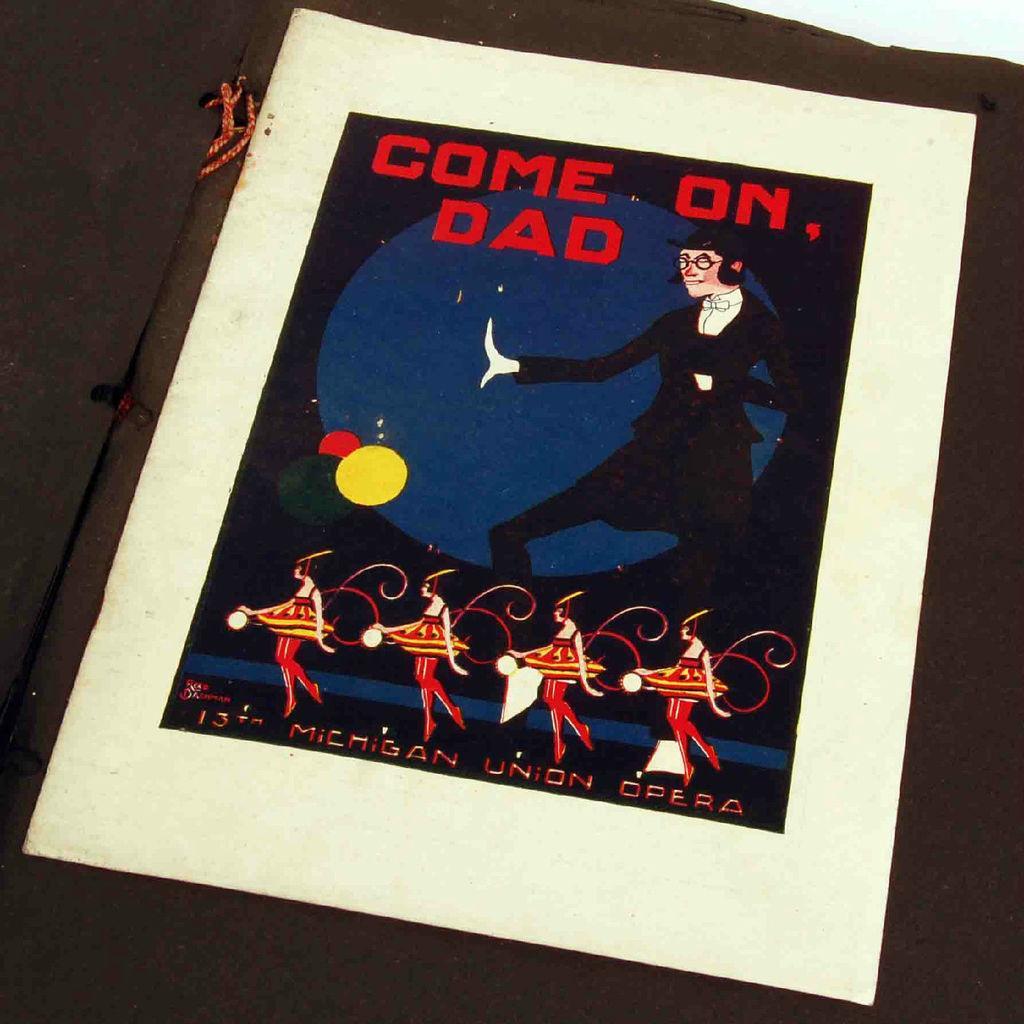Describe this image in one or two sentences. In the image we can see a poster. On the poster it was written "come on dad". A man was standing in this poster. In the bottom there are four ladies dancing. 